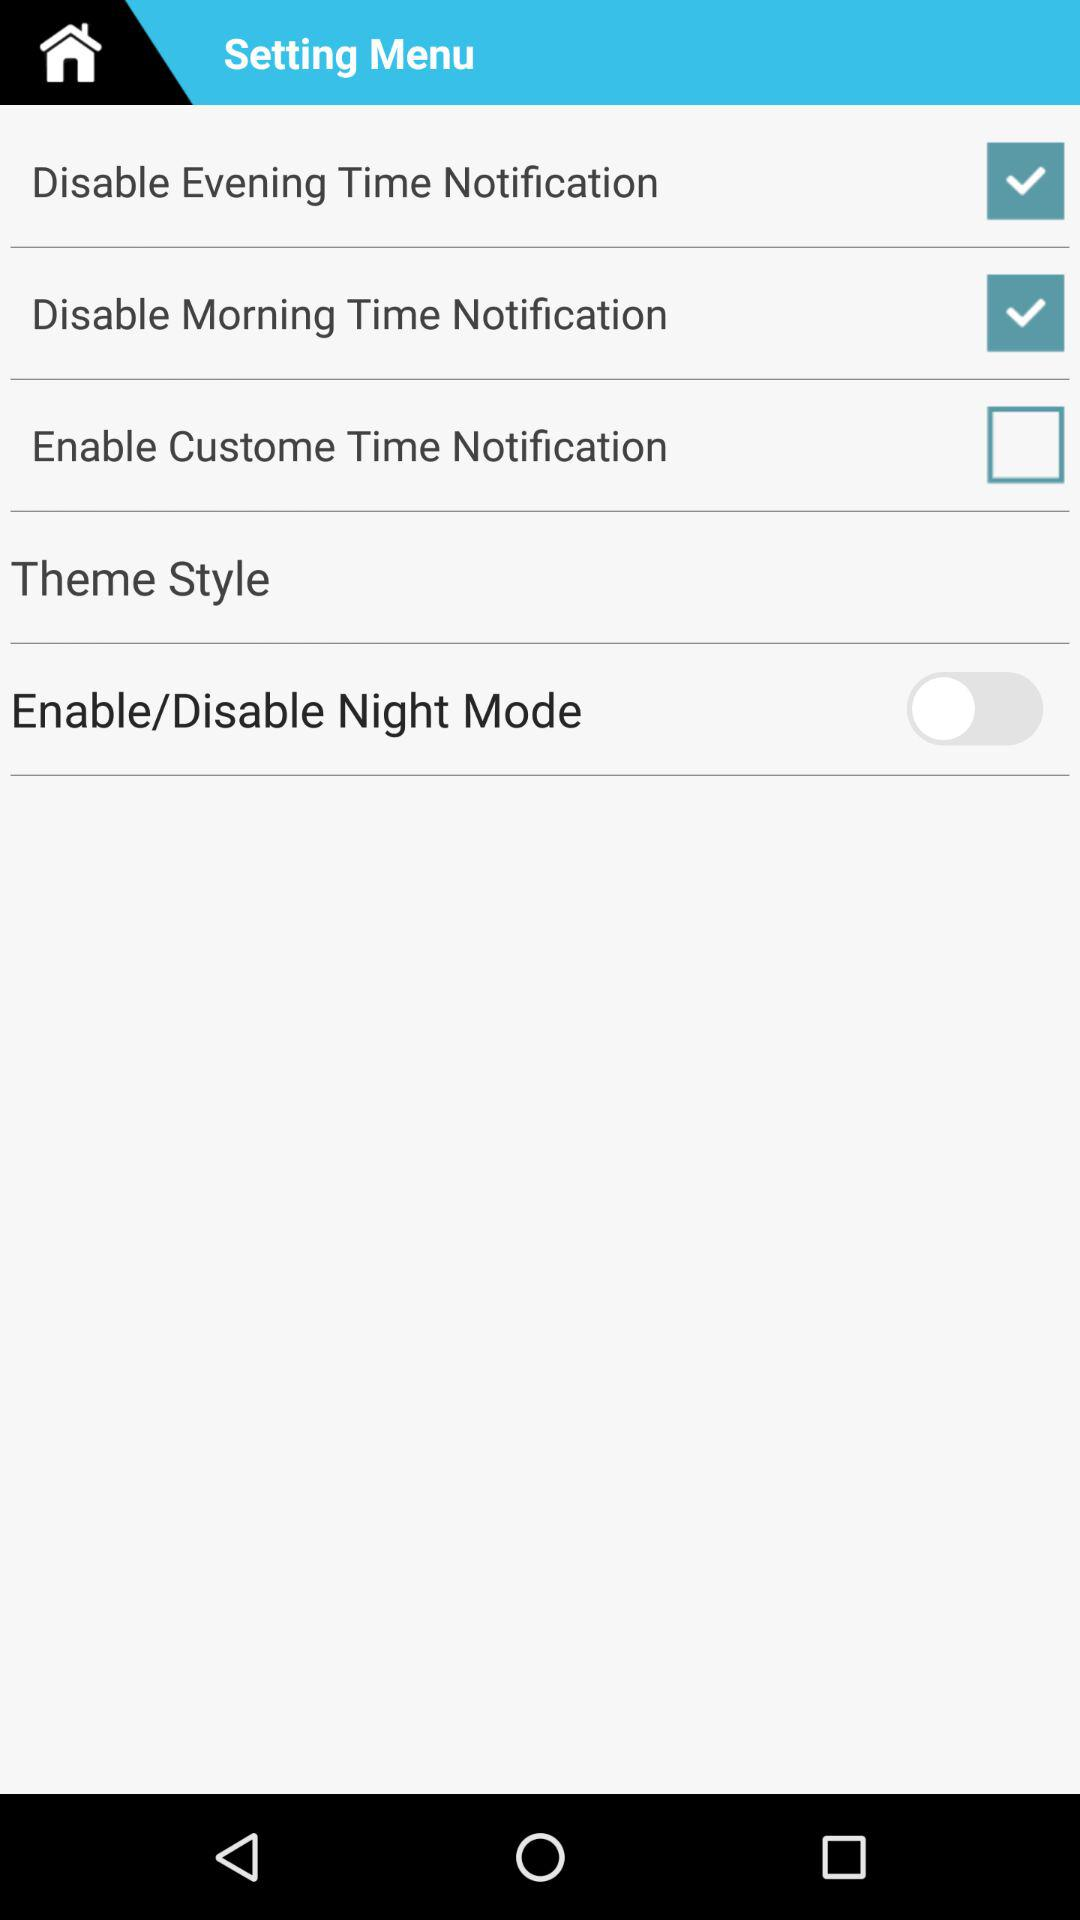Which is the selected checkbox? The selected checkboxes are "Disable Evening Time Notification" and "Disable Morning Time Notification". 